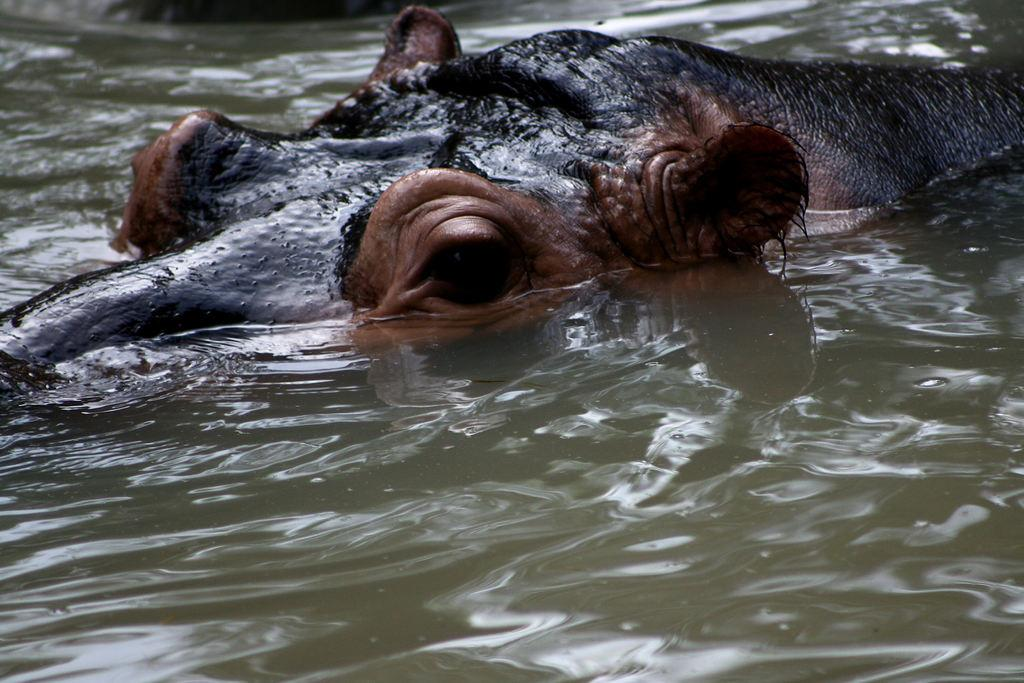What animal is present in the image? There is a hippopotamus in the image. Where is the hippopotamus located? The hippopotamus is in the water. What type of experience does the hippopotamus's dad have in the image? There is no dad or experience mentioned in the image, as it only features a hippopotamus in the water. 